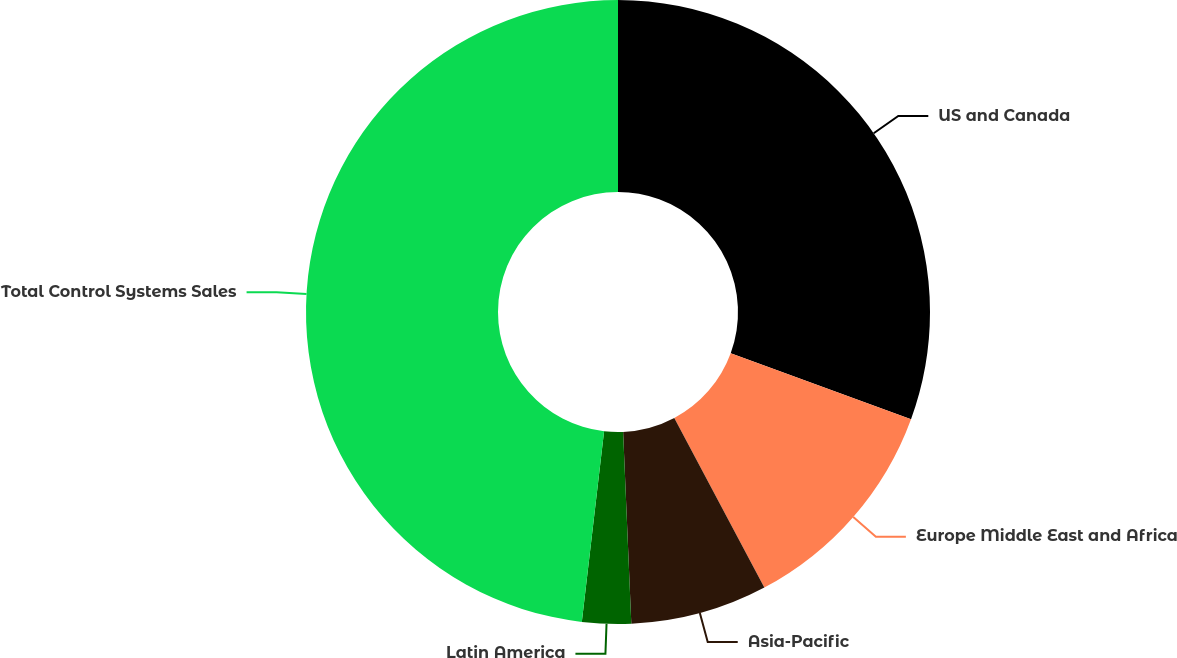Convert chart to OTSL. <chart><loc_0><loc_0><loc_500><loc_500><pie_chart><fcel>US and Canada<fcel>Europe Middle East and Africa<fcel>Asia-Pacific<fcel>Latin America<fcel>Total Control Systems Sales<nl><fcel>30.58%<fcel>11.65%<fcel>7.09%<fcel>2.53%<fcel>48.15%<nl></chart> 